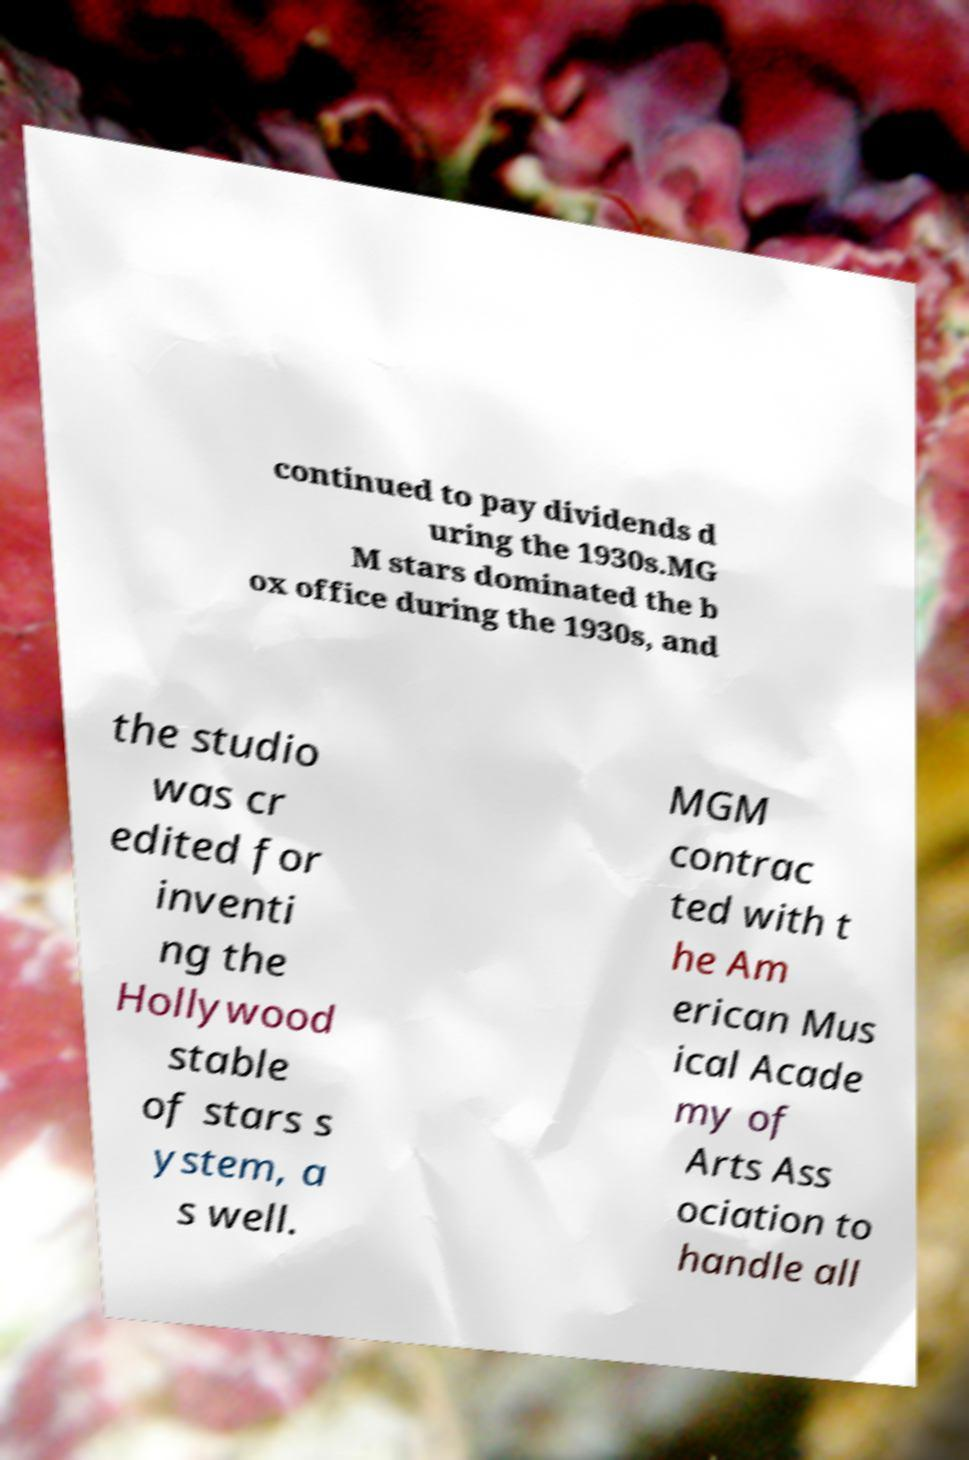Please read and relay the text visible in this image. What does it say? continued to pay dividends d uring the 1930s.MG M stars dominated the b ox office during the 1930s, and the studio was cr edited for inventi ng the Hollywood stable of stars s ystem, a s well. MGM contrac ted with t he Am erican Mus ical Acade my of Arts Ass ociation to handle all 